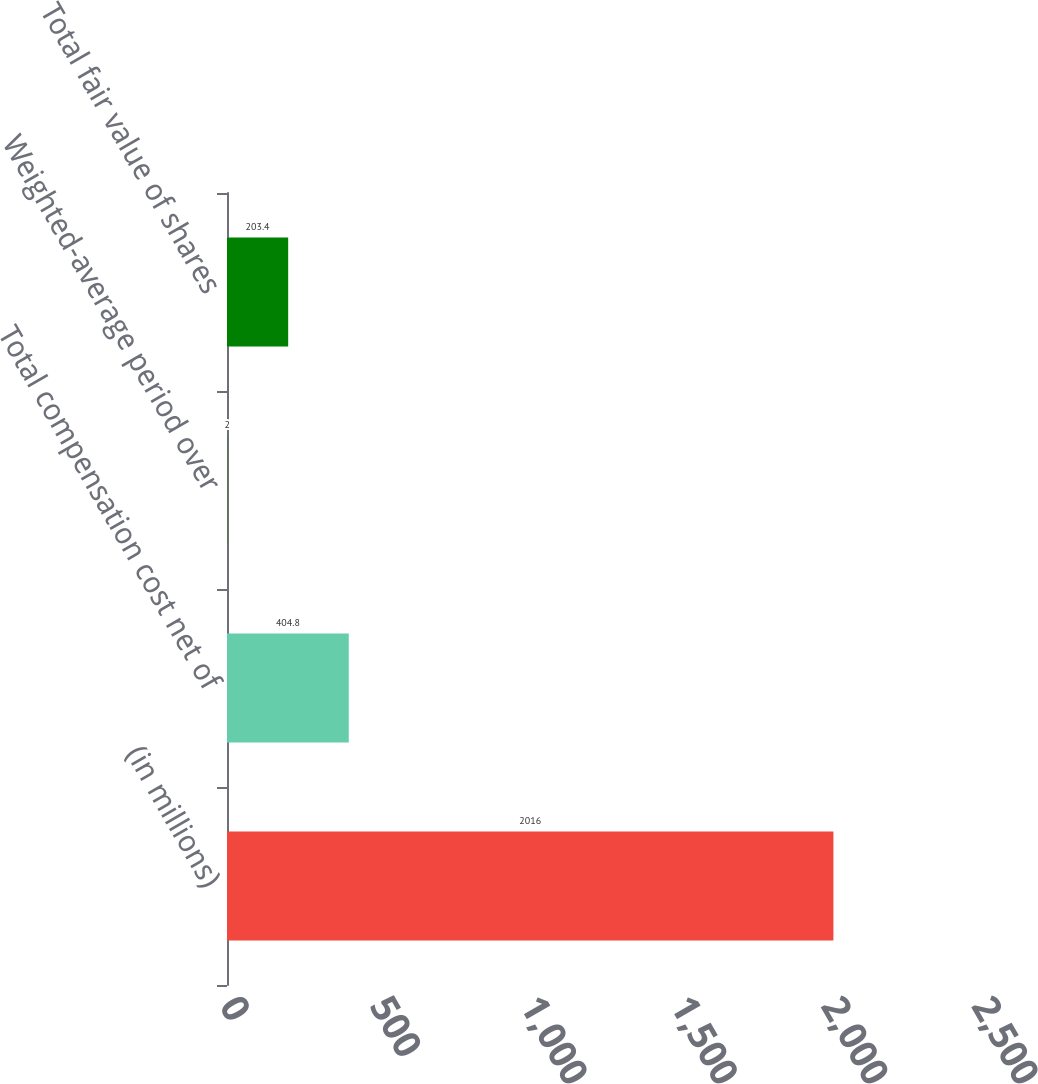Convert chart to OTSL. <chart><loc_0><loc_0><loc_500><loc_500><bar_chart><fcel>(in millions)<fcel>Total compensation cost net of<fcel>Weighted-average period over<fcel>Total fair value of shares<nl><fcel>2016<fcel>404.8<fcel>2<fcel>203.4<nl></chart> 